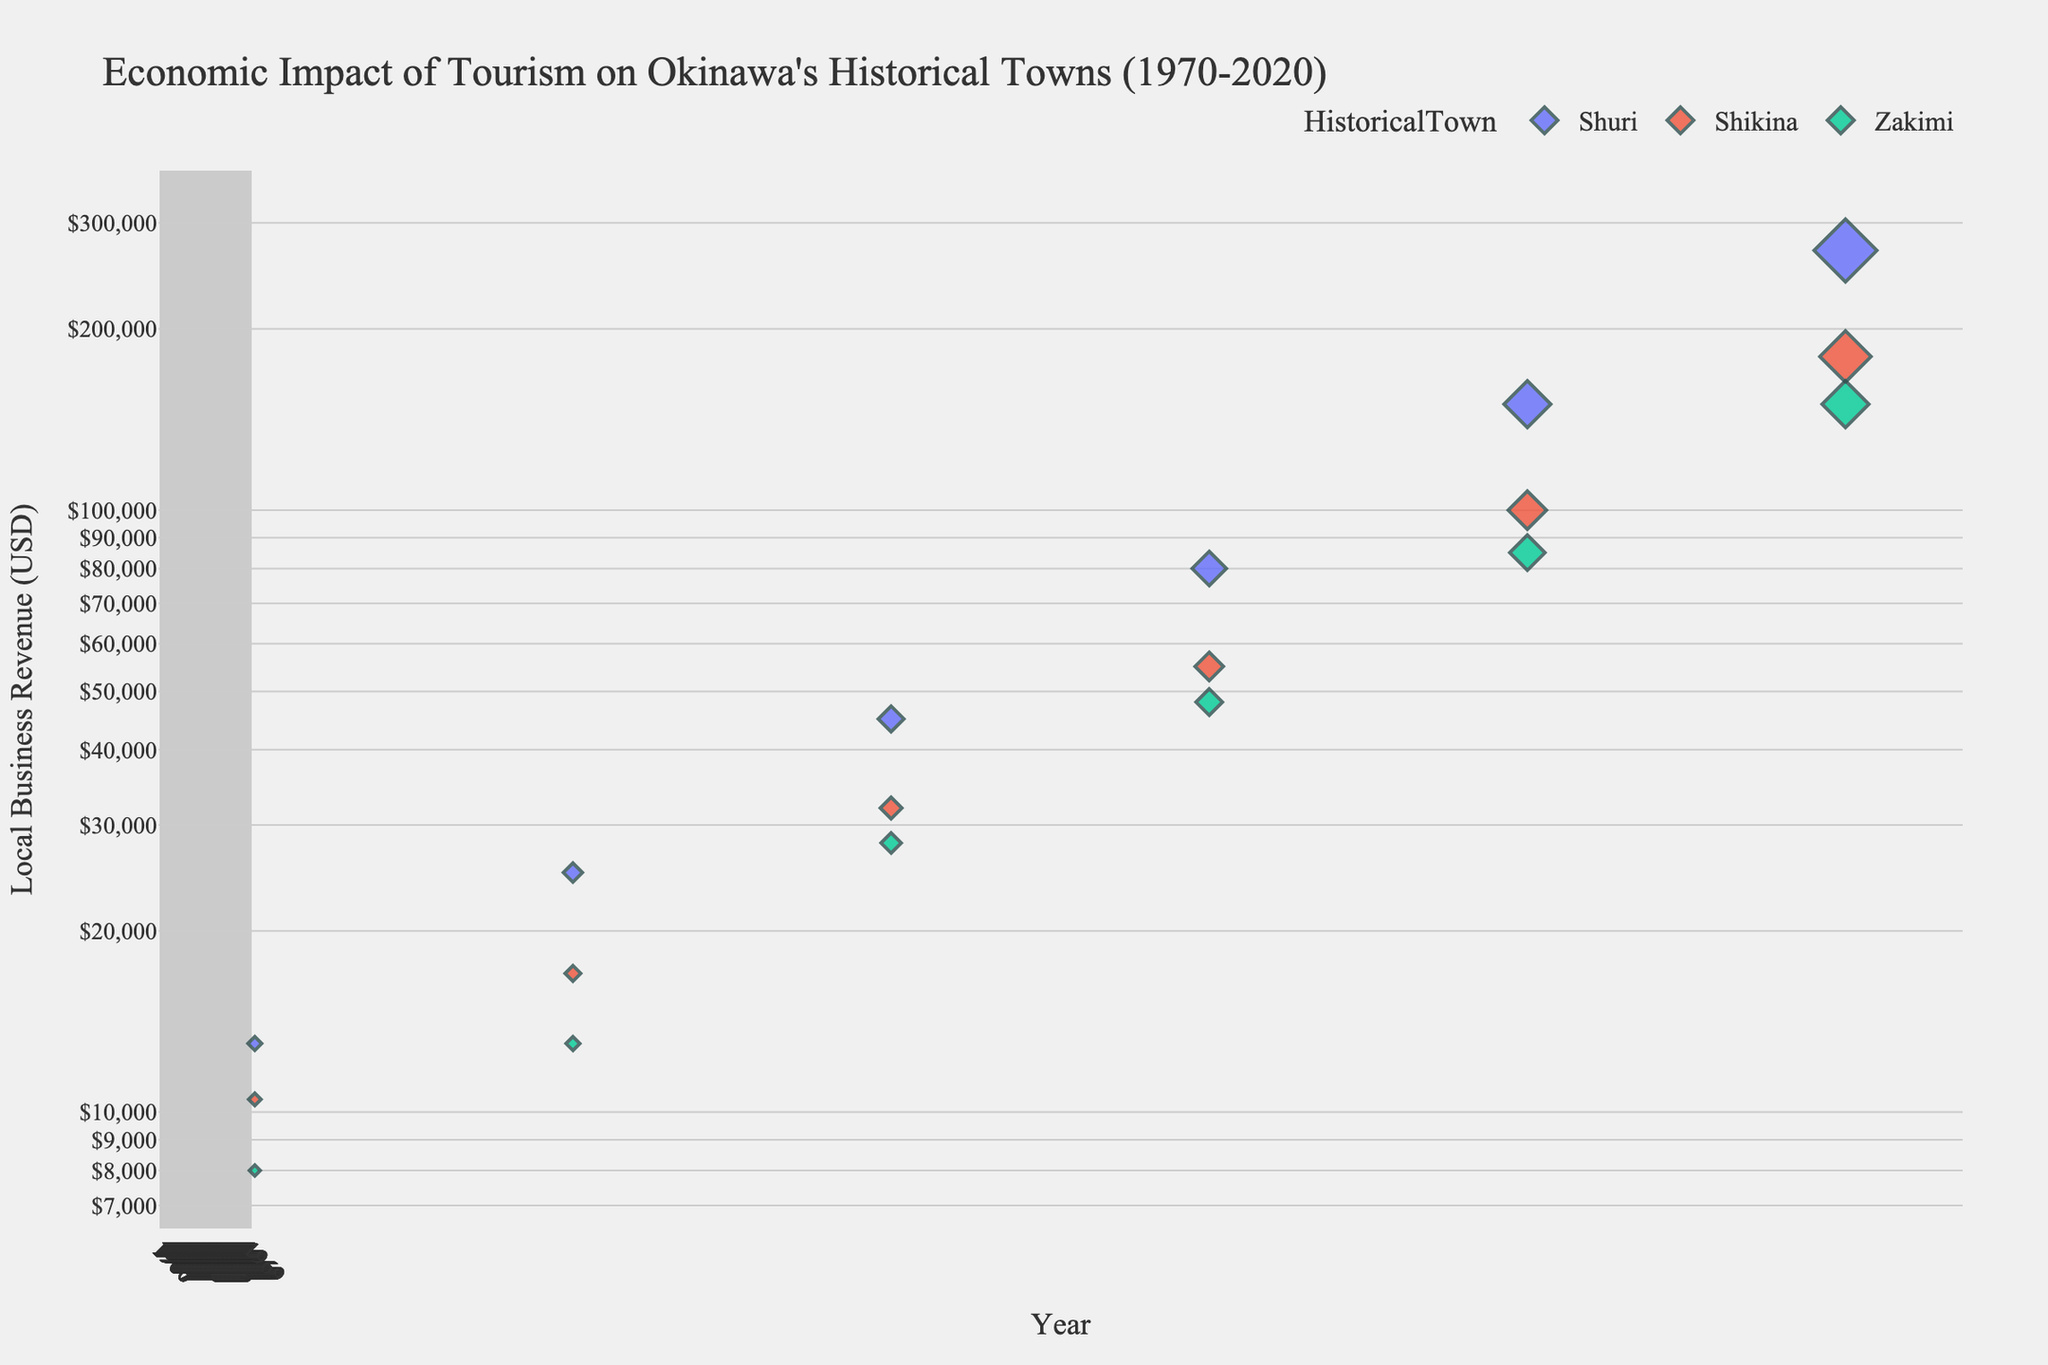What is the title of the scatter plot? The title is usually located at the top of the figure and gives a concise summary of what the figure represents. In this case, the plot's title is clearly written.
Answer: Economic Impact of Tourism on Okinawa's Historical Towns (1970-2020) What are the three historical towns represented in the scatter plot? By examining the legend to the right of the plot, we can see the names of the historical towns associated with different colors.
Answer: Shuri, Shikina, Zakimi Which town shows the highest local business revenue in 2020? We can identify the highest revenue by looking at the data points on the scatter plot for the year 2020 and comparing their positions on the y-axis.
Answer: Shuri What is the overall trend in local business revenue from 1970 to 2020 for Shuri? Observing the data points for Shuri over the years and noting their progression along the y-axis, we can determine the trend.
Answer: Increasing Between 1980 and 2020, which town had the greatest increase in local business revenue? By comparing the vertical distance (i.e., revenue increase) between data points for 1980 and 2020 for each town, we can find the town with the largest difference. Shuri: $270,000 - $25,000, Shikina: $180,000 - $17,000, Zakimi: $150,000 - $13,000. Calculate the differences: Shuri: $245,000, Shikina: $163,000, Zakimi: $137,000.
Answer: Shuri Which historical town had the lowest revenue in 1970? By looking at the lowest position on the y-axis among the data points for the year 1970, we can determine the town with the lowest revenue.
Answer: Zakimi What was the local business revenue for Shikina in 1990? By identifying the data point for Shikina in the year 1990 and reading its value from the y-axis, we can determine the revenue.
Answer: $32,000 How does the revenue of Shuri in 2000 compare to that of Zakimi in 2010? Comparing the positions of the data points for Shuri in 2000 and Zakimi in 2010 helps us determine if one is higher or lower than the other. Shuri in 2000: $80,000; Zakimi in 2010: $85,000.
Answer: Zakimi’s revenue in 2010 is higher On the log scale, how did the revenues for the three towns compare between 2010 and 2020? By comparing the data points for the respective years, we observe the relative change positions. If the data points show different proportional increases, that indicates different growth rates.
Answer: All towns experienced significant proportional increases What is the average revenue of all towns combined in 1980? First, find the revenue for each town in 1980—Shuri: $25,000, Shikina: $17,000, Zakimi: $13,000. Add these values to get the total, then divide by the number of towns (3). ($25,000 + $17,000 + $13,000) / 3 = $55,000 / 3.
Answer: ~$18,333 